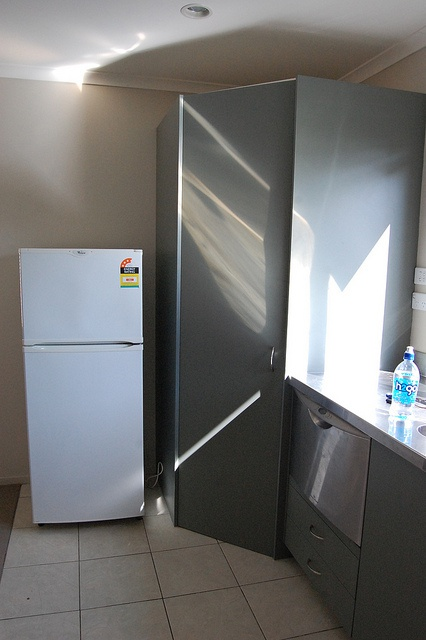Describe the objects in this image and their specific colors. I can see refrigerator in gray, darkgray, and lightgray tones, bottle in gray, white, cyan, lightblue, and darkgray tones, and sink in gray, lavender, and violet tones in this image. 